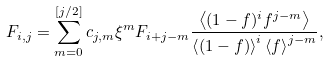Convert formula to latex. <formula><loc_0><loc_0><loc_500><loc_500>F _ { i , j } = \sum _ { m = 0 } ^ { [ j / 2 ] } c _ { j , m } \xi ^ { m } F _ { i + j - m } \frac { \left < ( 1 - f ) ^ { i } f ^ { j - m } \right > } { \left < ( 1 - f ) \right > ^ { i } \left < f \right > ^ { j - m } } ,</formula> 